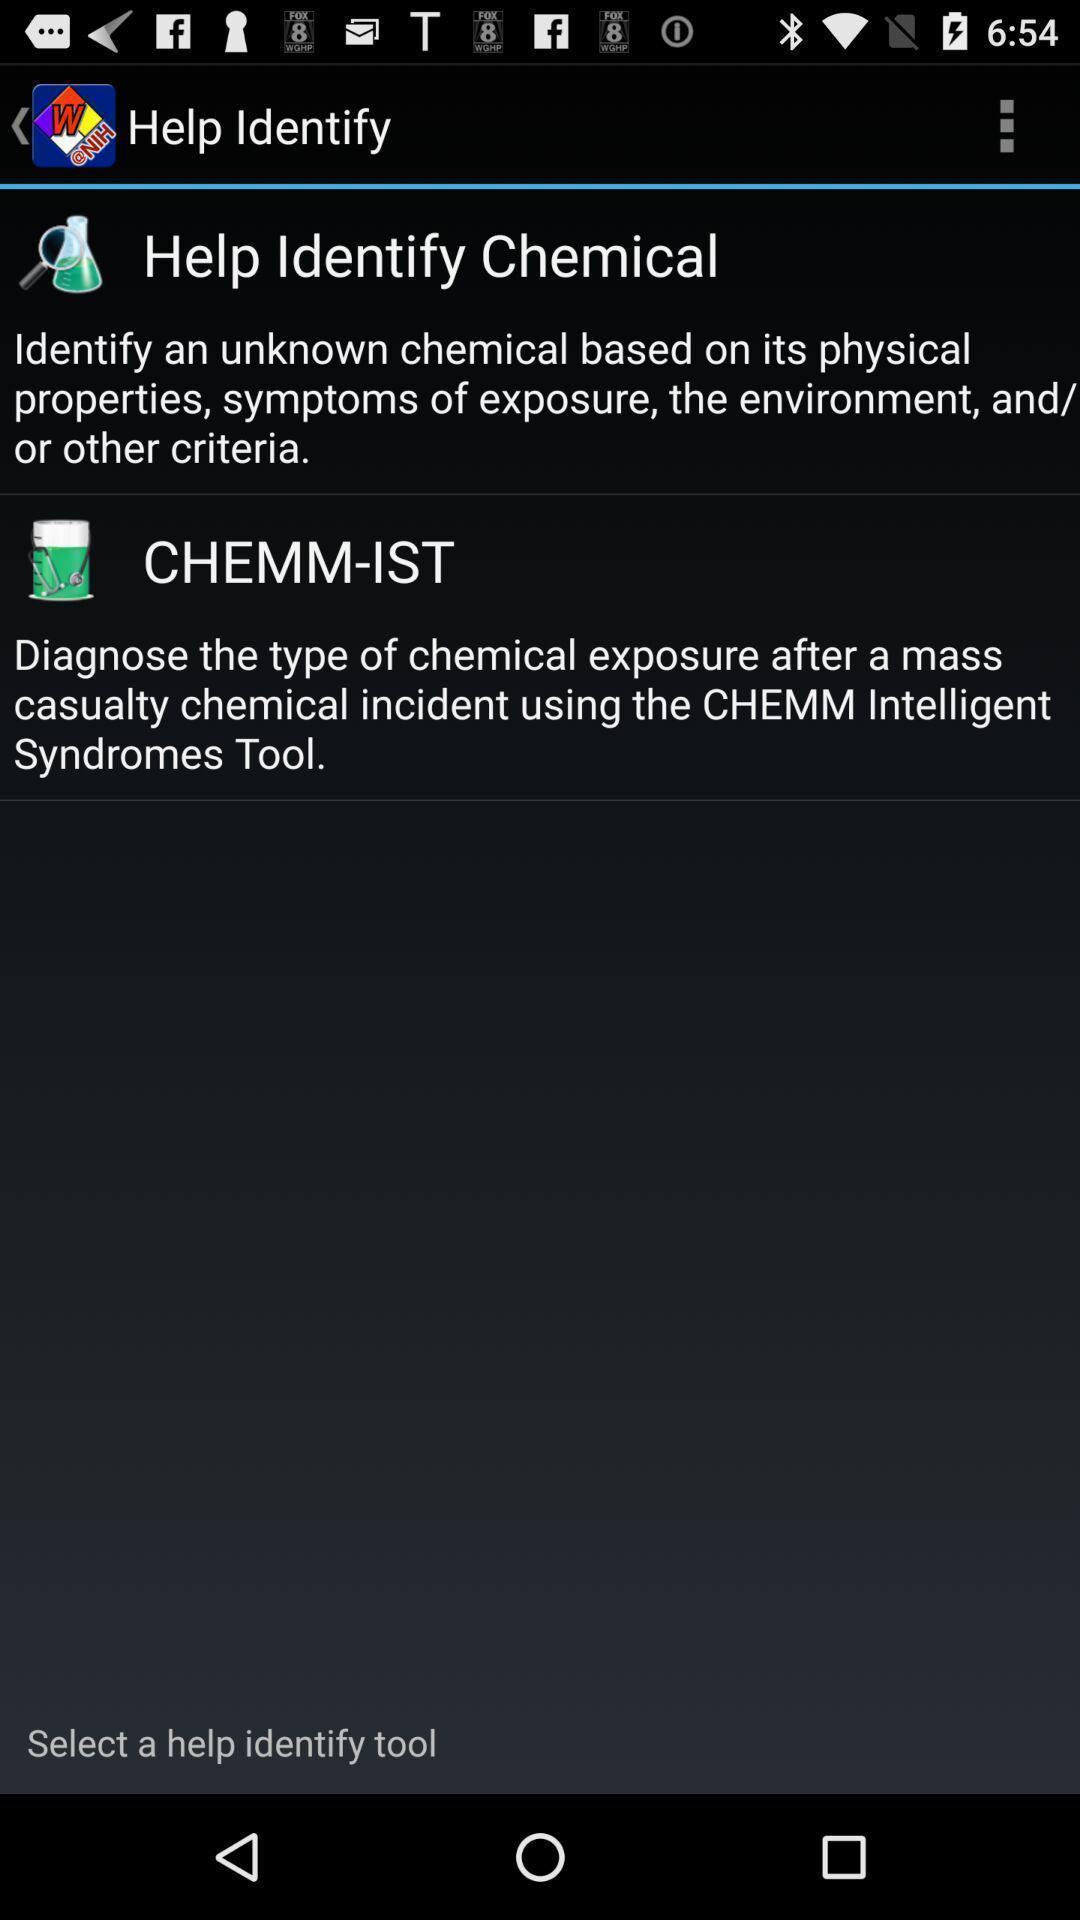Describe this image in words. Page showing information about application. 